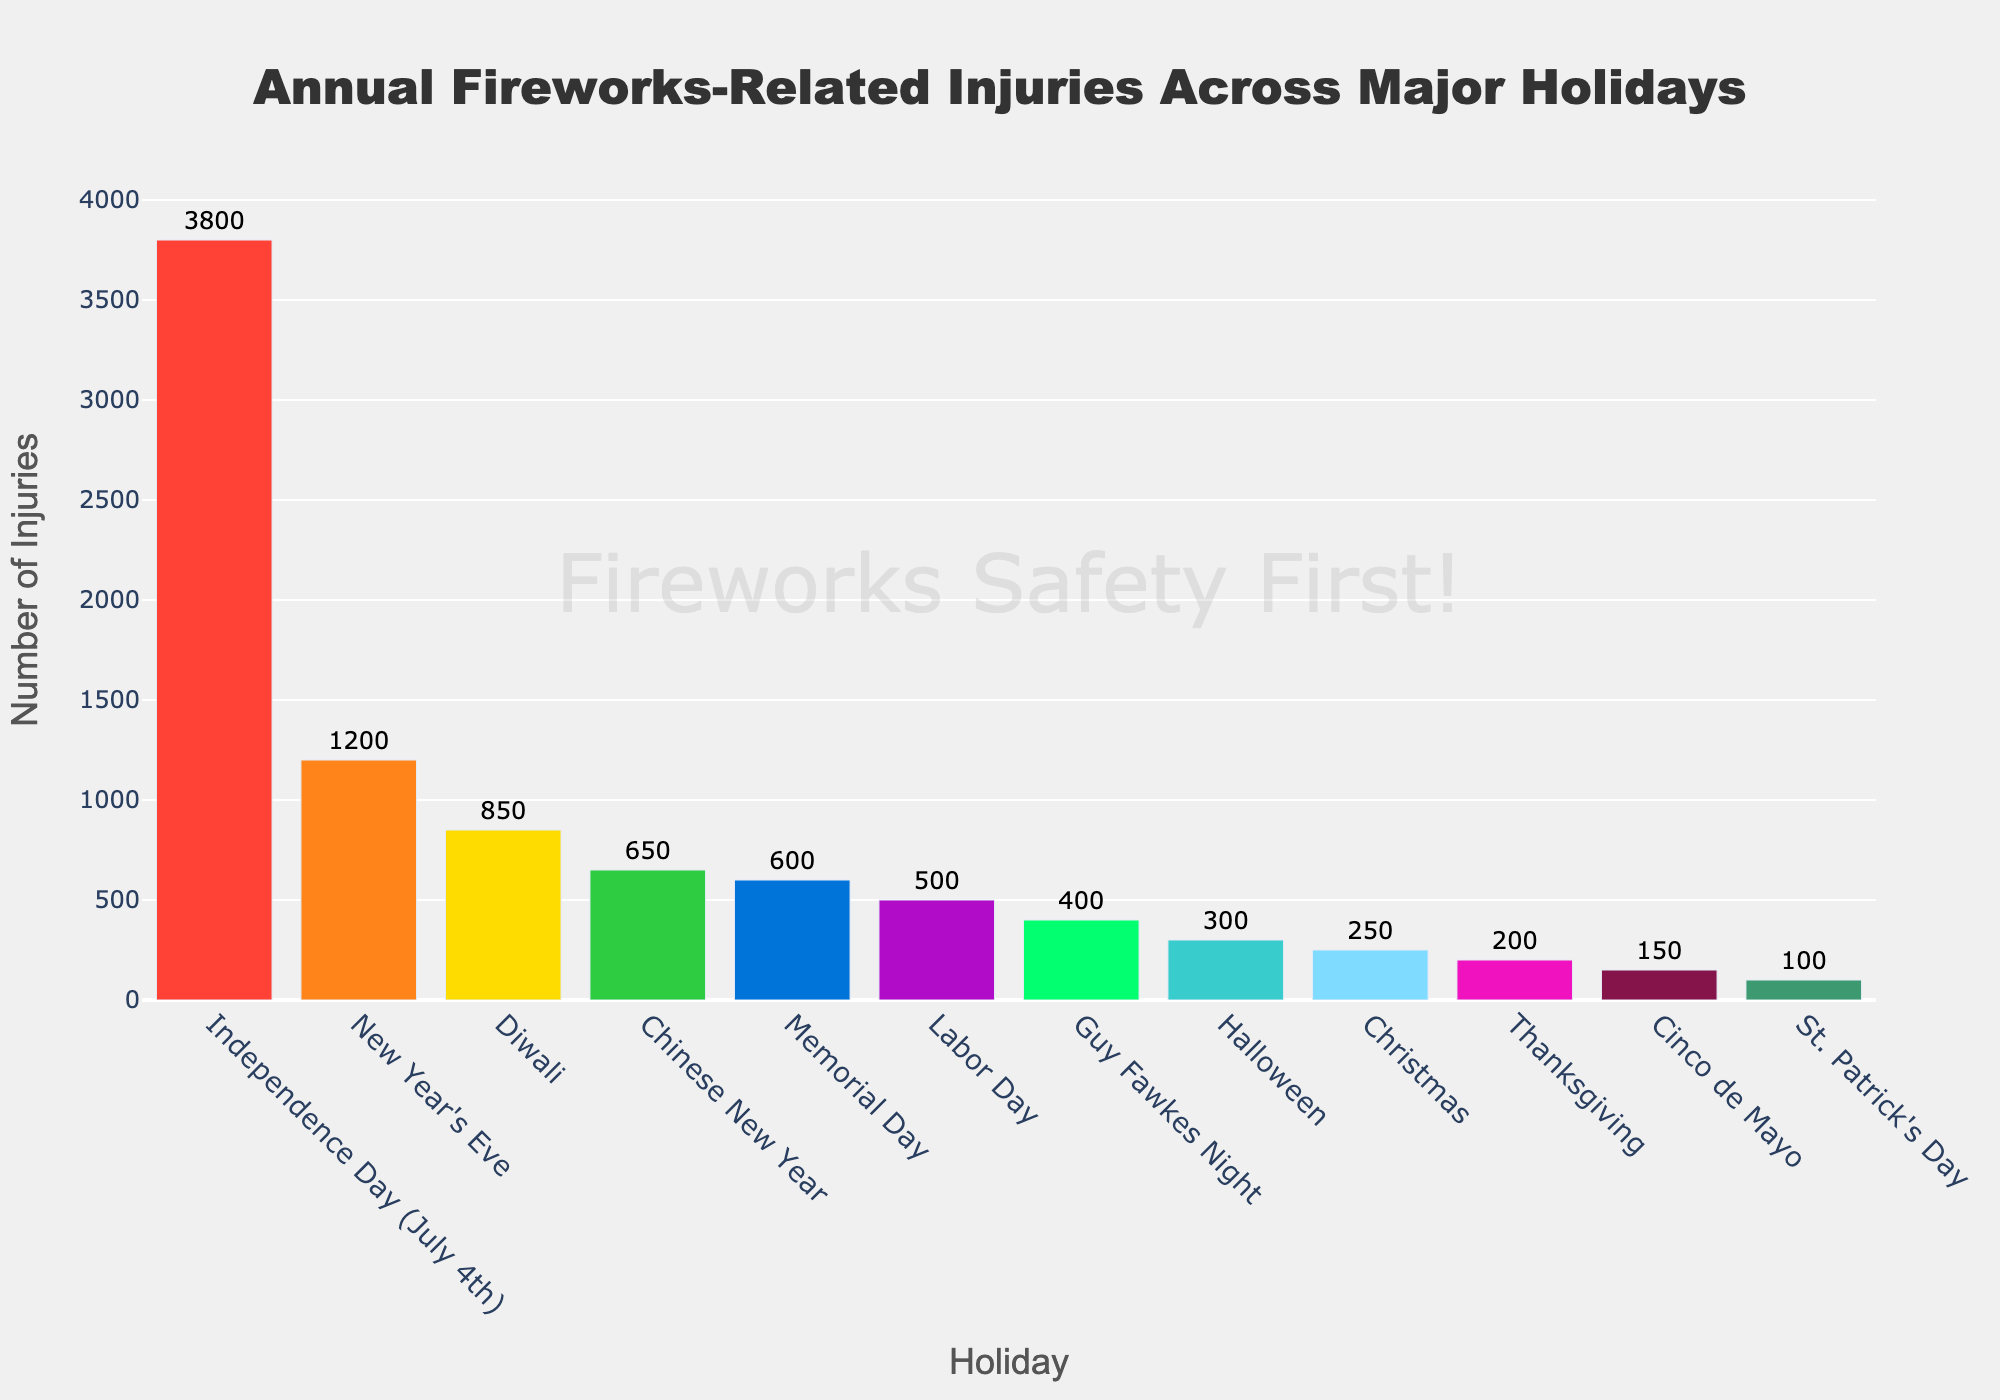Which holiday has the highest number of fireworks-related injuries? By looking at the bar with the greatest height, we can see that Independence Day (July 4th) has the highest number of injuries.
Answer: Independence Day (July 4th) How many more injuries occur on New Year's Eve than on Diwali? The bar for New Year's Eve represents 1200 injuries, while the bar for Diwali represents 850 injuries. The difference is 1200 - 850.
Answer: 350 What is the total number of injuries for the holidays New Year's Eve, Chinese New Year, and Diwali combined? Adding the injuries for these three holidays: 1200 (New Year's Eve) + 650 (Chinese New Year) + 850 (Diwali) equals 2700.
Answer: 2700 Is Memorial Day or Labor Day associated with more fireworks injuries? By comparing the heights of the bars, we can see that Memorial Day (600 injuries) has more injuries than Labor Day (500 injuries).
Answer: Memorial Day What is the average number of injuries across all listed holidays? Sum the injuries for all holidays and divide by the number of holidays. (1200 + 3800 + 650 + 850 + 400 + 250 + 600 + 500 + 300 + 150 + 100 + 200) / 12 equals 900.
Answer: 900 How much higher are the injuries on July 4th compared to Thanksgiving? The bar for Independence Day (July 4th) shows 3800 injuries and for Thanksgiving shows 200 injuries. The difference is 3800 - 200.
Answer: 3600 Which holiday has the lowest number of fireworks-related injuries? The shortest bar corresponds to St. Patrick's Day with 100 injuries.
Answer: St. Patrick's Day Are there more injuries on Halloween or on Guy Fawkes Night? Comparing the heights of the bars, Halloween (300 injuries) has more injuries than Guy Fawkes Night (400 injuries).
Answer: Guy Fawkes Night What is the total number of injuries for holidays occurring in the winter season (New Year's Eve, Christmas, Thanksgiving)? Adding the injuries for these holidays: New Year's Eve (1200) + Christmas (250) + Thanksgiving (200) equals 1650.
Answer: 1650 